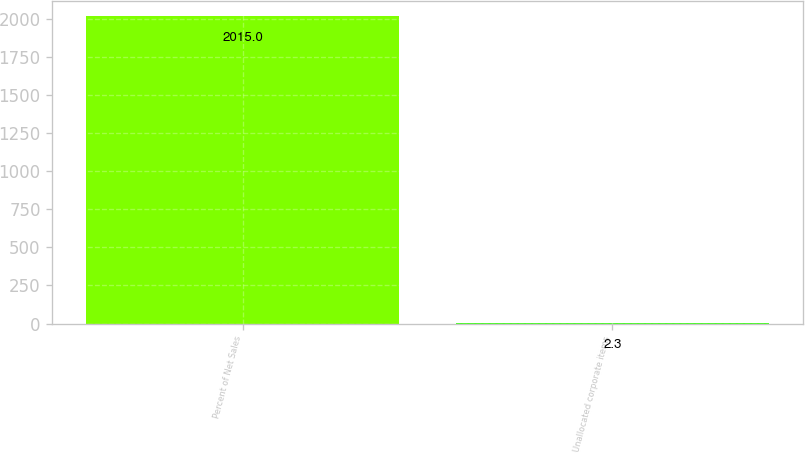<chart> <loc_0><loc_0><loc_500><loc_500><bar_chart><fcel>Percent of Net Sales<fcel>Unallocated corporate items<nl><fcel>2015<fcel>2.3<nl></chart> 